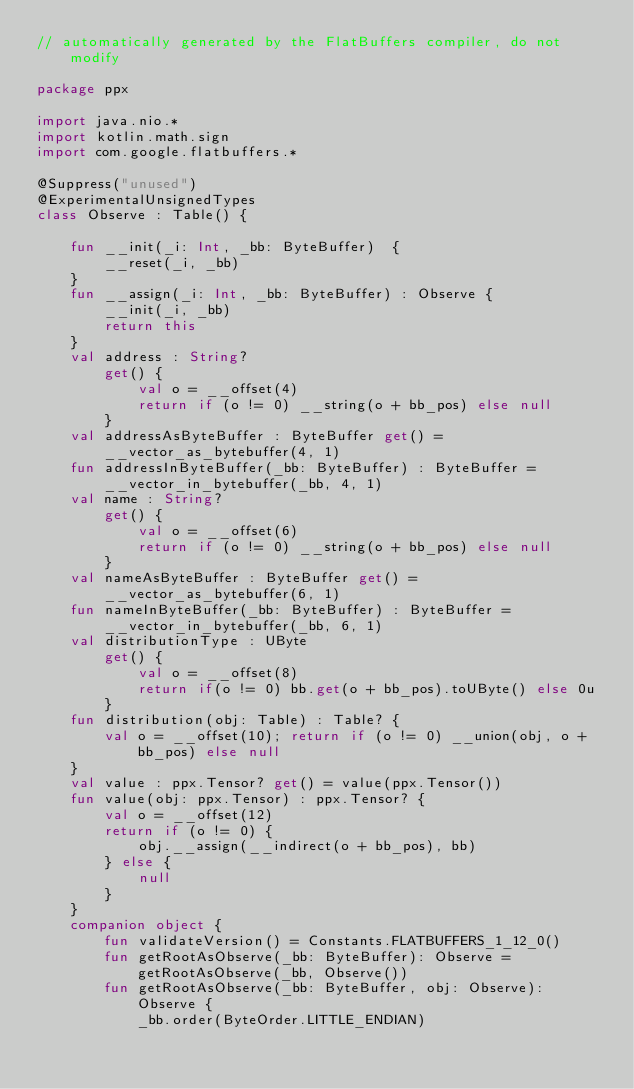<code> <loc_0><loc_0><loc_500><loc_500><_Kotlin_>// automatically generated by the FlatBuffers compiler, do not modify

package ppx

import java.nio.*
import kotlin.math.sign
import com.google.flatbuffers.*

@Suppress("unused")
@ExperimentalUnsignedTypes
class Observe : Table() {

    fun __init(_i: Int, _bb: ByteBuffer)  {
        __reset(_i, _bb)
    }
    fun __assign(_i: Int, _bb: ByteBuffer) : Observe {
        __init(_i, _bb)
        return this
    }
    val address : String?
        get() {
            val o = __offset(4)
            return if (o != 0) __string(o + bb_pos) else null
        }
    val addressAsByteBuffer : ByteBuffer get() = __vector_as_bytebuffer(4, 1)
    fun addressInByteBuffer(_bb: ByteBuffer) : ByteBuffer = __vector_in_bytebuffer(_bb, 4, 1)
    val name : String?
        get() {
            val o = __offset(6)
            return if (o != 0) __string(o + bb_pos) else null
        }
    val nameAsByteBuffer : ByteBuffer get() = __vector_as_bytebuffer(6, 1)
    fun nameInByteBuffer(_bb: ByteBuffer) : ByteBuffer = __vector_in_bytebuffer(_bb, 6, 1)
    val distributionType : UByte
        get() {
            val o = __offset(8)
            return if(o != 0) bb.get(o + bb_pos).toUByte() else 0u
        }
    fun distribution(obj: Table) : Table? {
        val o = __offset(10); return if (o != 0) __union(obj, o + bb_pos) else null
    }
    val value : ppx.Tensor? get() = value(ppx.Tensor())
    fun value(obj: ppx.Tensor) : ppx.Tensor? {
        val o = __offset(12)
        return if (o != 0) {
            obj.__assign(__indirect(o + bb_pos), bb)
        } else {
            null
        }
    }
    companion object {
        fun validateVersion() = Constants.FLATBUFFERS_1_12_0()
        fun getRootAsObserve(_bb: ByteBuffer): Observe = getRootAsObserve(_bb, Observe())
        fun getRootAsObserve(_bb: ByteBuffer, obj: Observe): Observe {
            _bb.order(ByteOrder.LITTLE_ENDIAN)</code> 